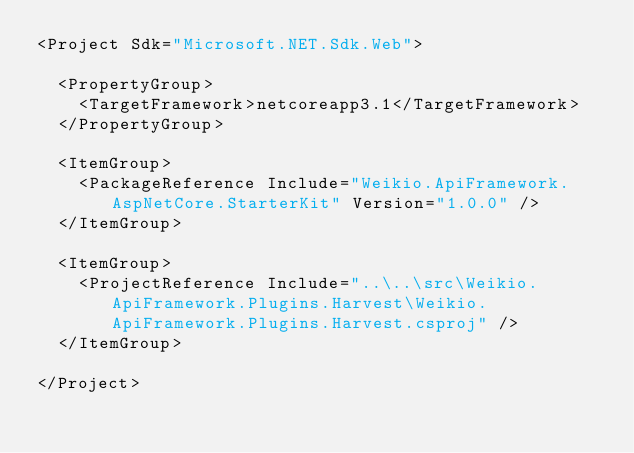Convert code to text. <code><loc_0><loc_0><loc_500><loc_500><_XML_><Project Sdk="Microsoft.NET.Sdk.Web">

  <PropertyGroup>
    <TargetFramework>netcoreapp3.1</TargetFramework>
  </PropertyGroup>

  <ItemGroup>
    <PackageReference Include="Weikio.ApiFramework.AspNetCore.StarterKit" Version="1.0.0" />
  </ItemGroup>

  <ItemGroup>
    <ProjectReference Include="..\..\src\Weikio.ApiFramework.Plugins.Harvest\Weikio.ApiFramework.Plugins.Harvest.csproj" />
  </ItemGroup>
  
</Project>
</code> 